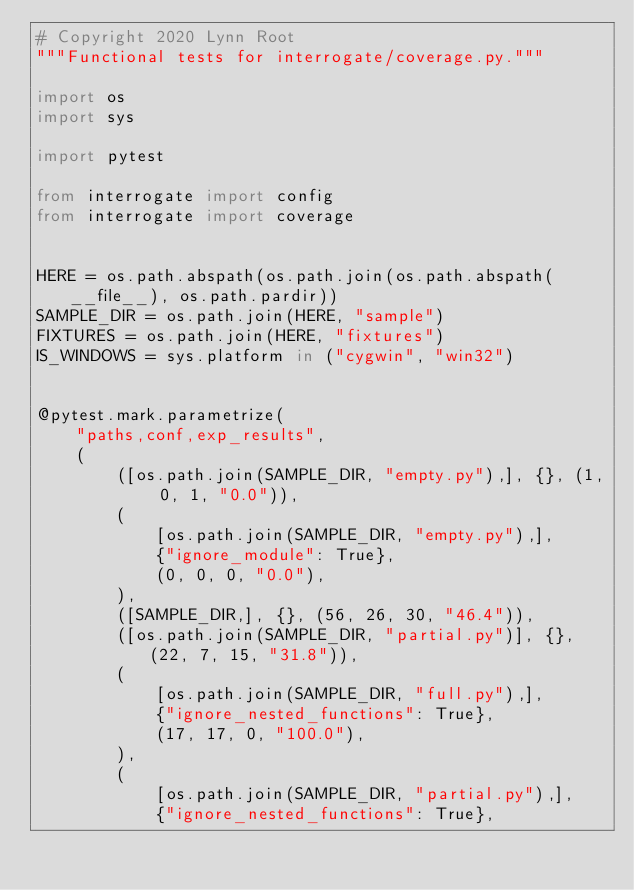<code> <loc_0><loc_0><loc_500><loc_500><_Python_># Copyright 2020 Lynn Root
"""Functional tests for interrogate/coverage.py."""

import os
import sys

import pytest

from interrogate import config
from interrogate import coverage


HERE = os.path.abspath(os.path.join(os.path.abspath(__file__), os.path.pardir))
SAMPLE_DIR = os.path.join(HERE, "sample")
FIXTURES = os.path.join(HERE, "fixtures")
IS_WINDOWS = sys.platform in ("cygwin", "win32")


@pytest.mark.parametrize(
    "paths,conf,exp_results",
    (
        ([os.path.join(SAMPLE_DIR, "empty.py"),], {}, (1, 0, 1, "0.0")),
        (
            [os.path.join(SAMPLE_DIR, "empty.py"),],
            {"ignore_module": True},
            (0, 0, 0, "0.0"),
        ),
        ([SAMPLE_DIR,], {}, (56, 26, 30, "46.4")),
        ([os.path.join(SAMPLE_DIR, "partial.py")], {}, (22, 7, 15, "31.8")),
        (
            [os.path.join(SAMPLE_DIR, "full.py"),],
            {"ignore_nested_functions": True},
            (17, 17, 0, "100.0"),
        ),
        (
            [os.path.join(SAMPLE_DIR, "partial.py"),],
            {"ignore_nested_functions": True},</code> 